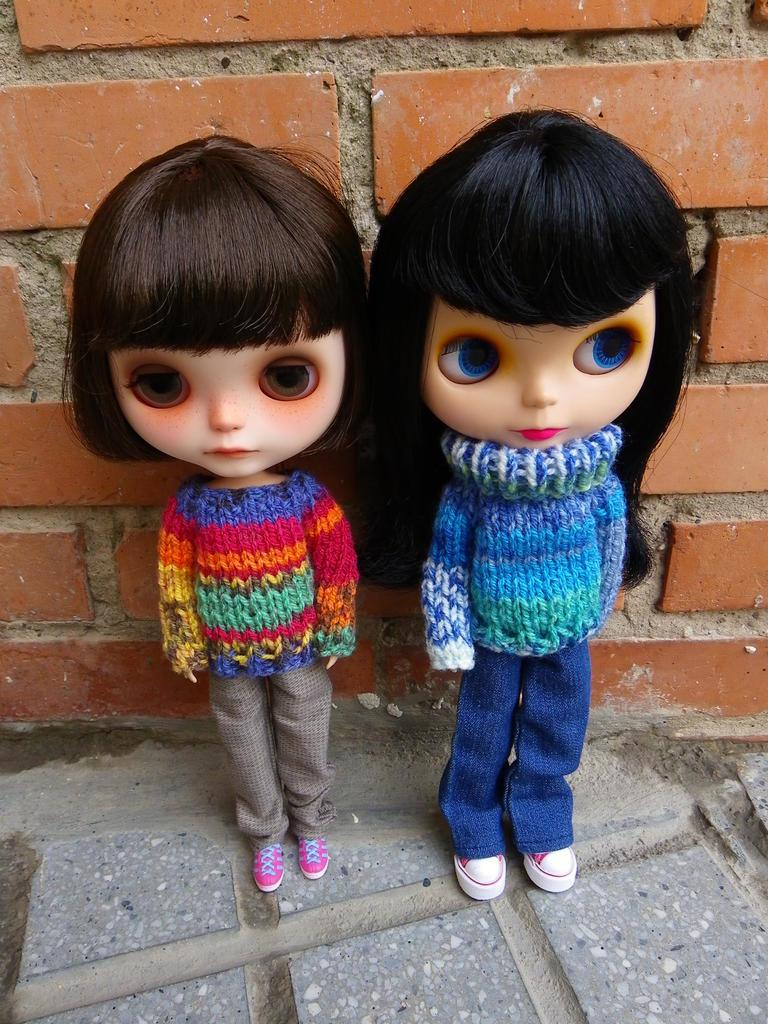How many dolls are present in the image? There are two dolls in the image. What can be seen in the background of the image? There is a brick wall in the background of the image. What type of pot is being used to enforce the rule in the image? There is no pot or rule present in the image; it features two dolls and a brick wall in the background. 